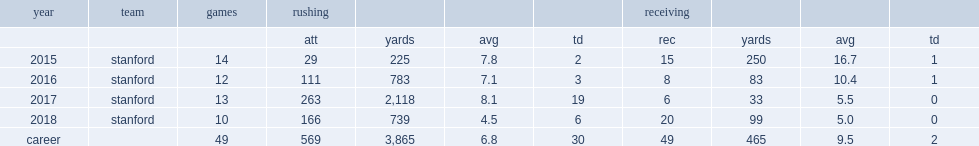How many rushing yards did bryce love finish the year with? 739.0. How many rushing touchdowns did bryce love finish the year with? 6.0. 